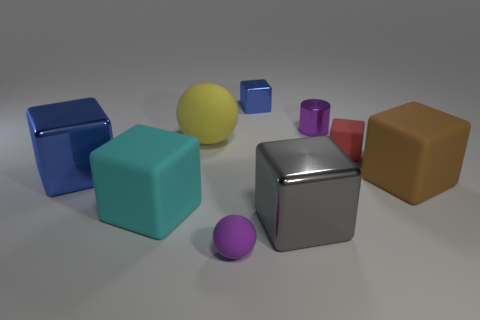Subtract all blue cubes. How many cubes are left? 4 Subtract all big gray cubes. How many cubes are left? 5 Subtract all green cubes. Subtract all cyan cylinders. How many cubes are left? 6 Add 1 green matte cylinders. How many objects exist? 10 Subtract all spheres. How many objects are left? 7 Add 3 big rubber cubes. How many big rubber cubes exist? 5 Subtract 0 cyan balls. How many objects are left? 9 Subtract all small objects. Subtract all cyan blocks. How many objects are left? 4 Add 4 matte balls. How many matte balls are left? 6 